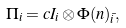<formula> <loc_0><loc_0><loc_500><loc_500>\Pi _ { i } = c I _ { i } \otimes \Phi ( n ) _ { \bar { i } } ,</formula> 